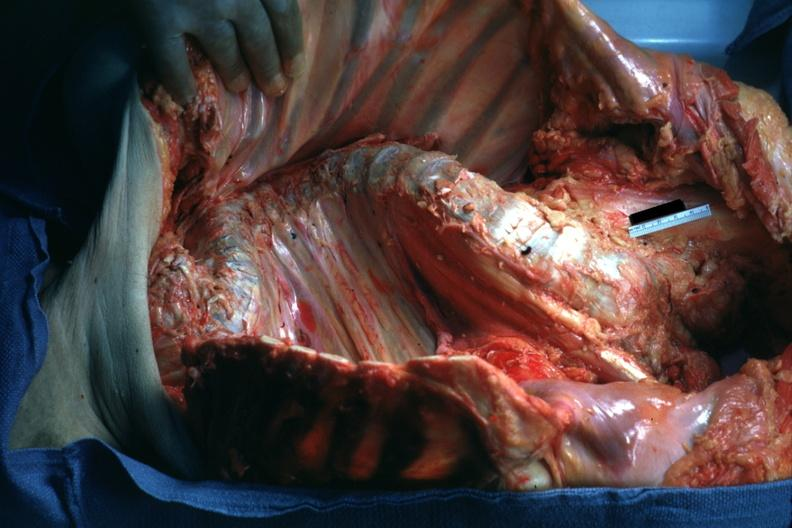s metastatic carcinoma x-ray present?
Answer the question using a single word or phrase. No 